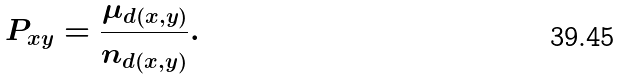Convert formula to latex. <formula><loc_0><loc_0><loc_500><loc_500>P _ { x y } = \frac { \mu _ { d ( x , y ) } } { n _ { d ( x , y ) } } .</formula> 